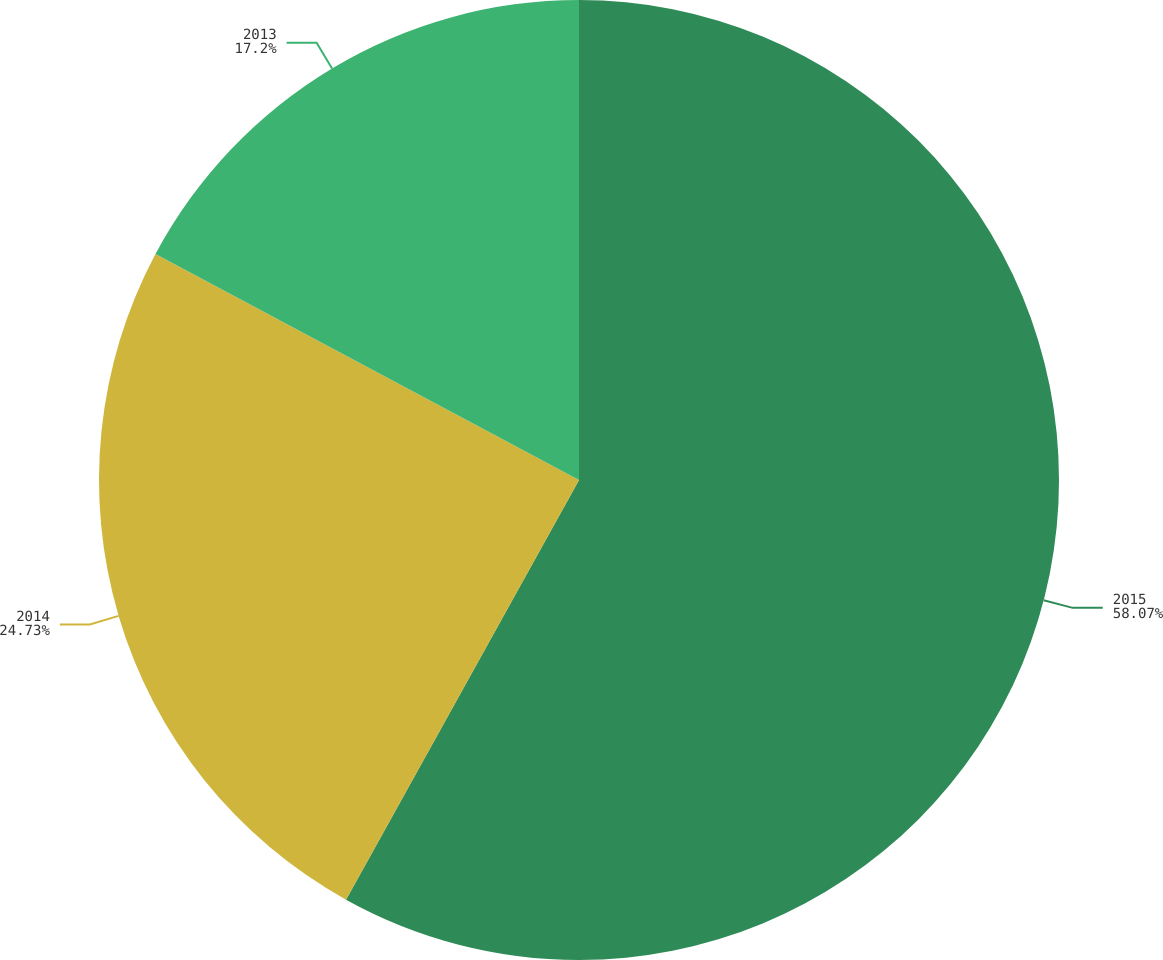Convert chart to OTSL. <chart><loc_0><loc_0><loc_500><loc_500><pie_chart><fcel>2015<fcel>2014<fcel>2013<nl><fcel>58.06%<fcel>24.73%<fcel>17.2%<nl></chart> 